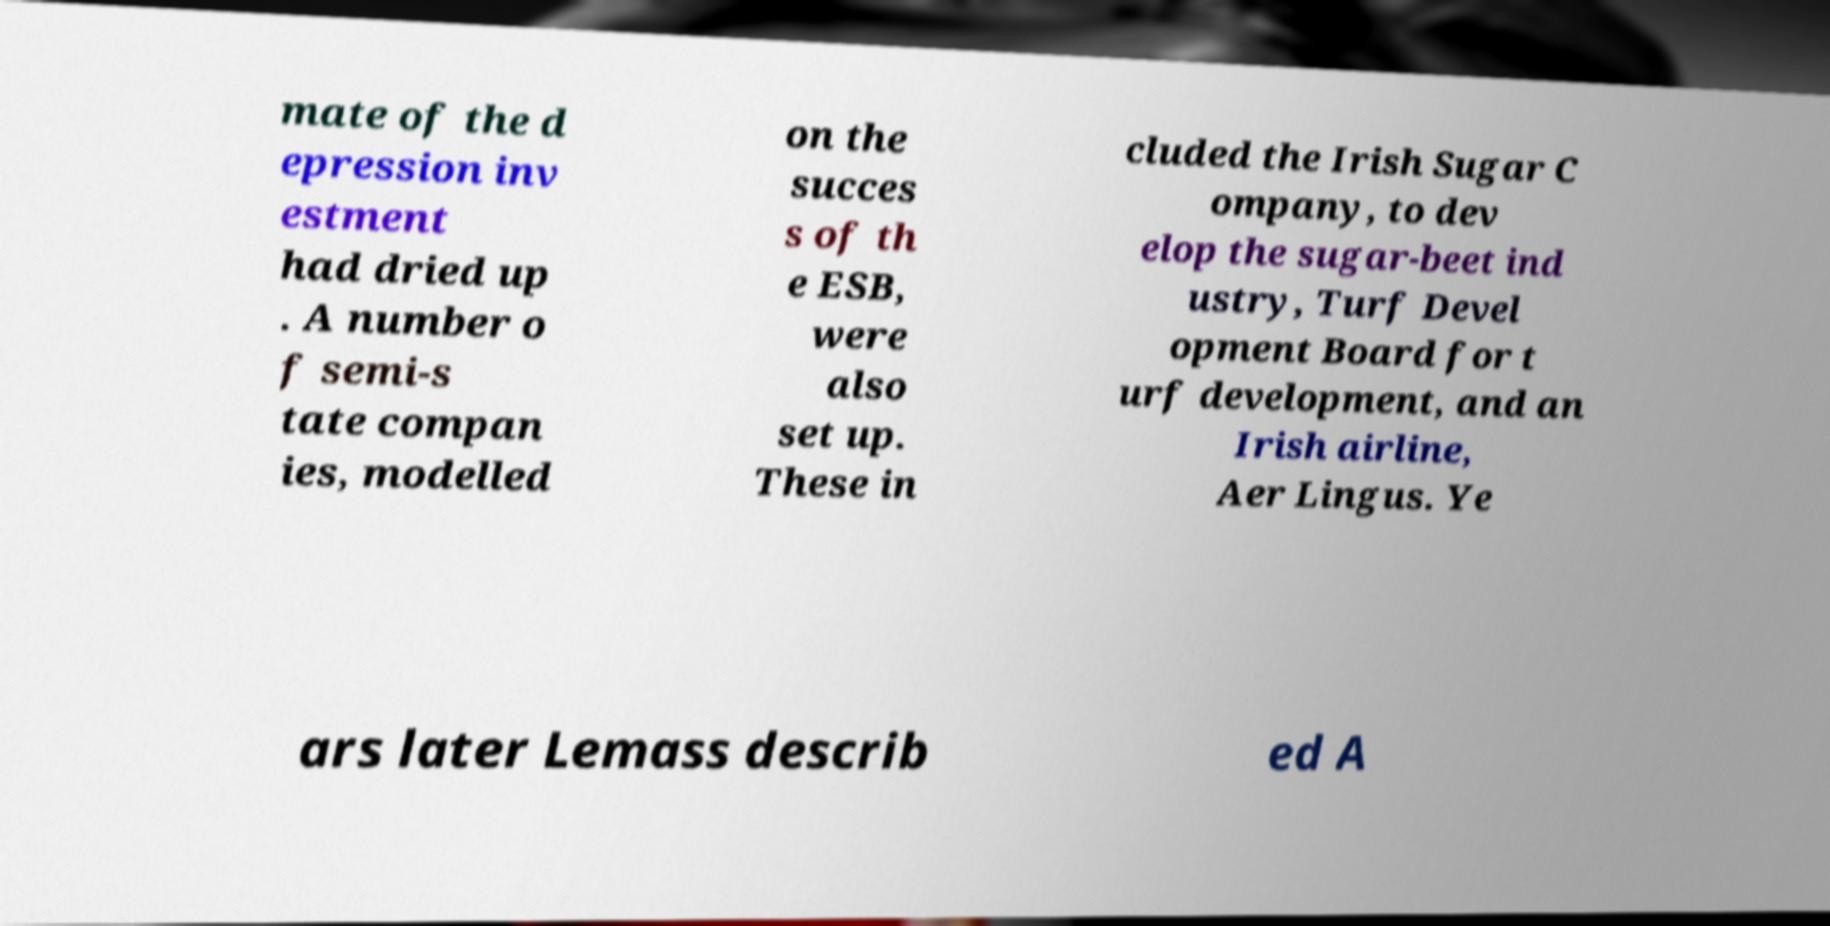Can you accurately transcribe the text from the provided image for me? mate of the d epression inv estment had dried up . A number o f semi-s tate compan ies, modelled on the succes s of th e ESB, were also set up. These in cluded the Irish Sugar C ompany, to dev elop the sugar-beet ind ustry, Turf Devel opment Board for t urf development, and an Irish airline, Aer Lingus. Ye ars later Lemass describ ed A 